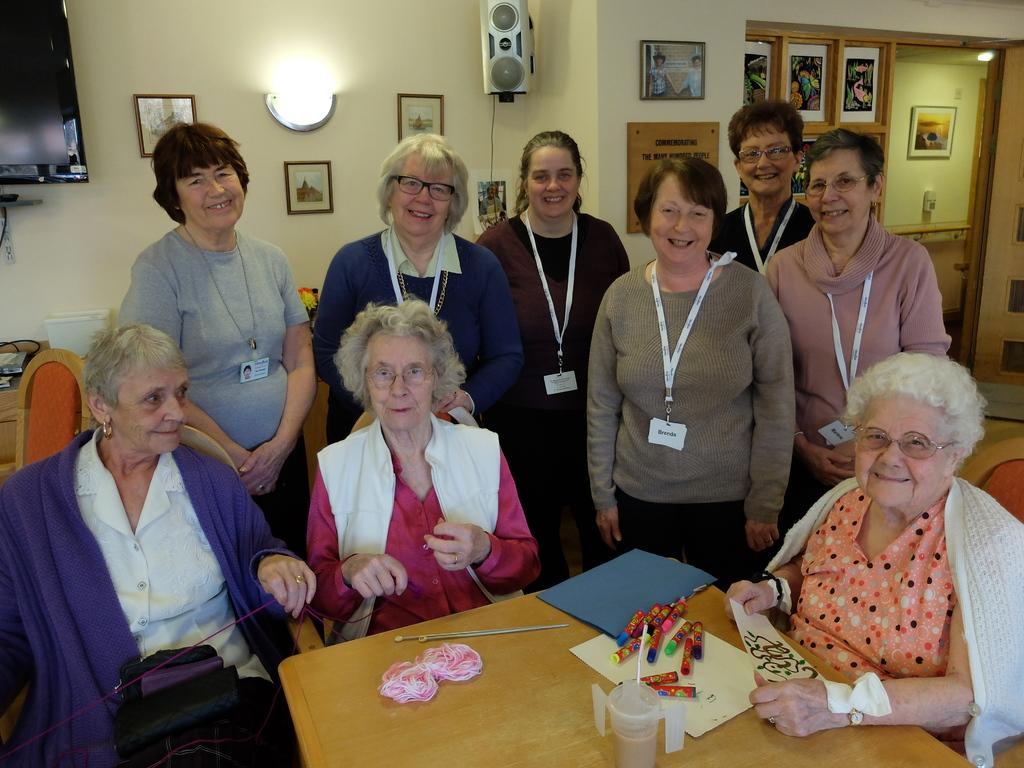In one or two sentences, can you explain what this image depicts? In this picture there are group of persons were three among them are sitting in chairs and there is a table in front of them which has few objects on it and the remaining are standing and there are few photo frames are attached to the wall in the background and there is a television in the left top corner. 